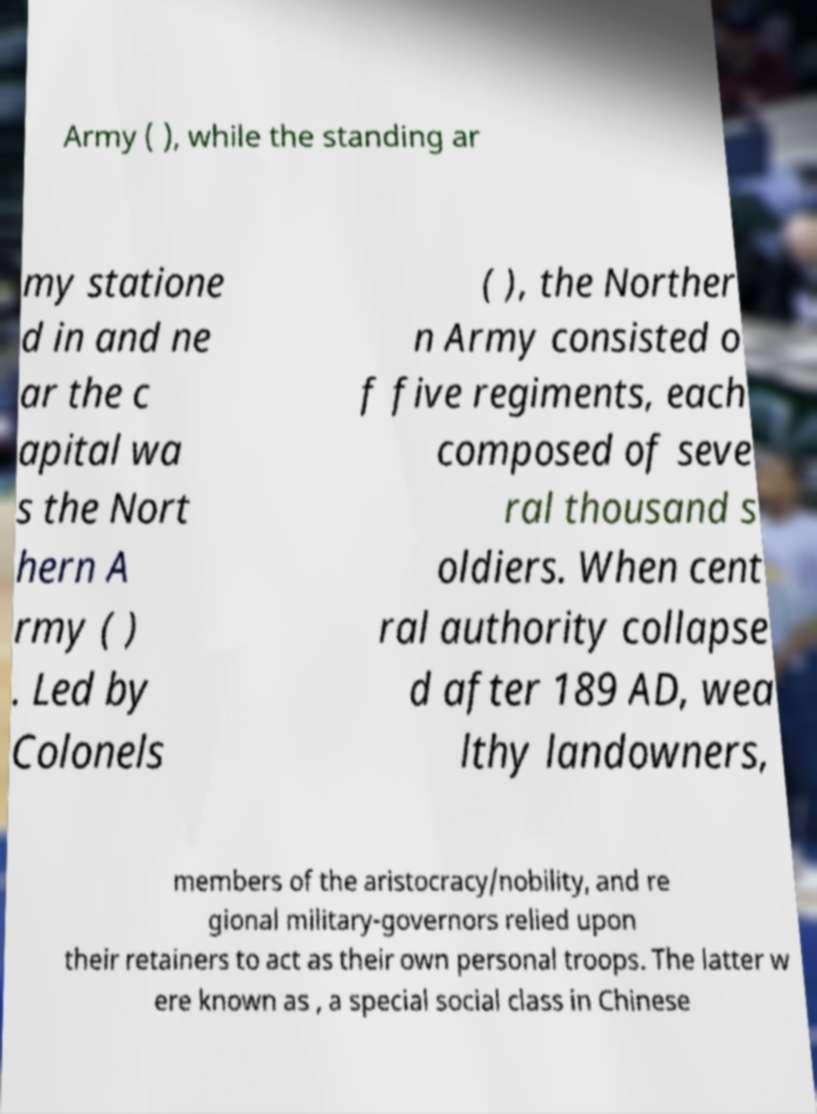There's text embedded in this image that I need extracted. Can you transcribe it verbatim? Army ( ), while the standing ar my statione d in and ne ar the c apital wa s the Nort hern A rmy ( ) . Led by Colonels ( ), the Norther n Army consisted o f five regiments, each composed of seve ral thousand s oldiers. When cent ral authority collapse d after 189 AD, wea lthy landowners, members of the aristocracy/nobility, and re gional military-governors relied upon their retainers to act as their own personal troops. The latter w ere known as , a special social class in Chinese 